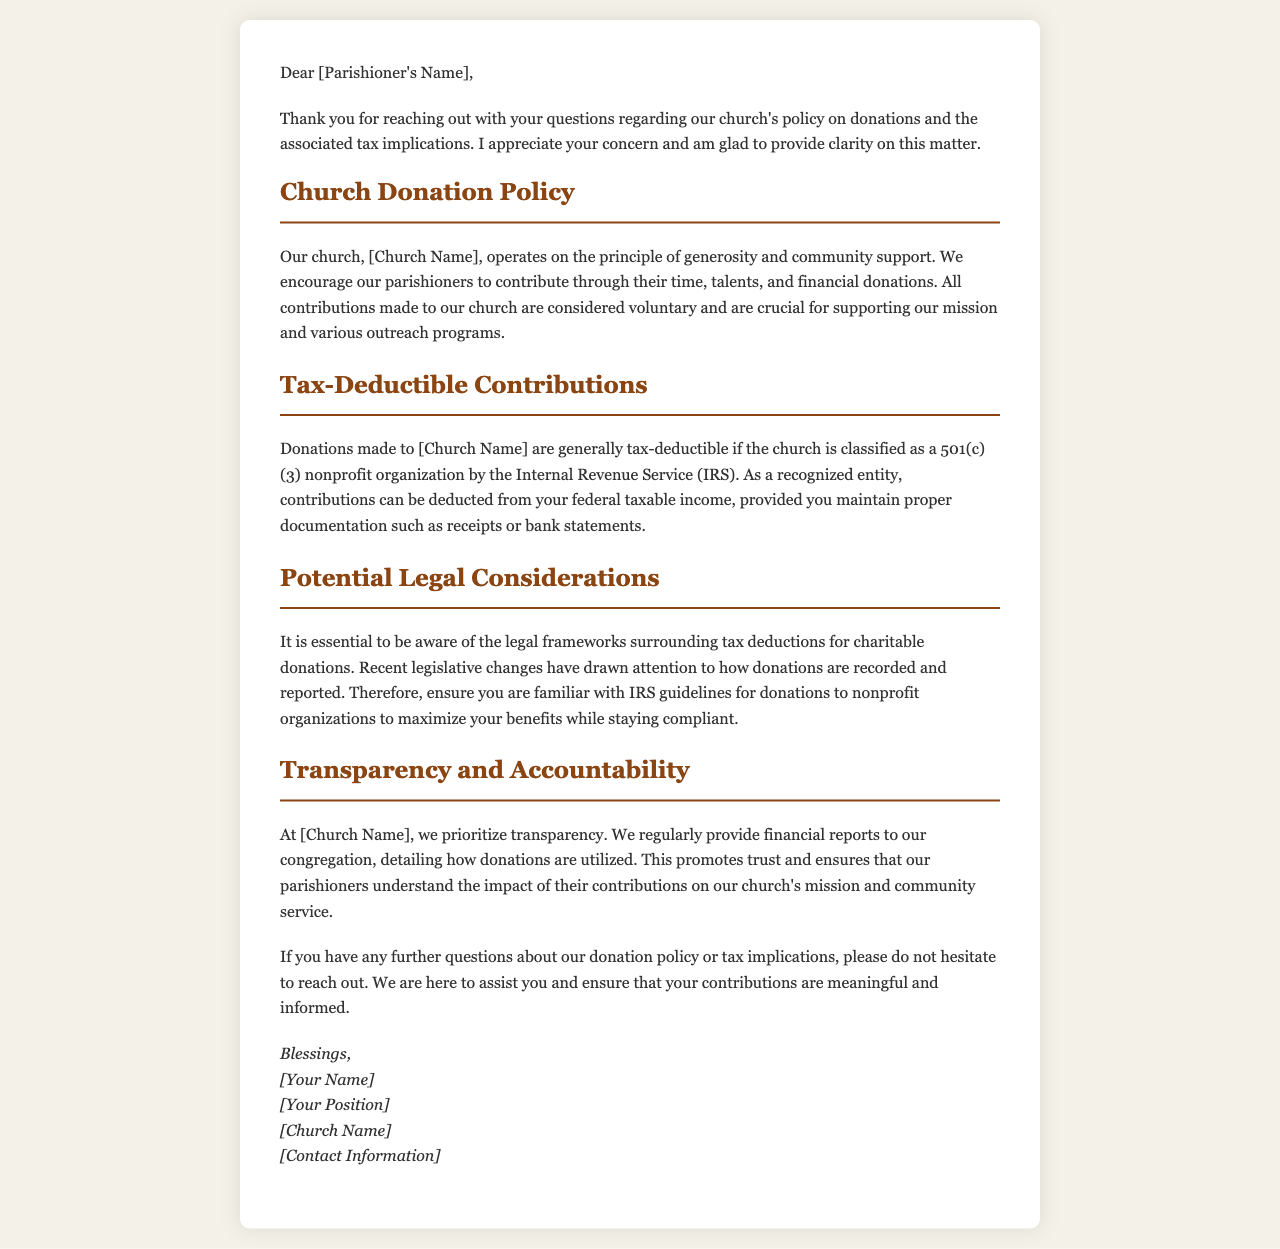What is the church's principle of operation? The church operates on the principle of generosity and community support, indicating its core values and mission.
Answer: Generosity and community support What type of organization is [Church Name] classified as? The church is classified as a 501(c)(3) nonprofit organization by the Internal Revenue Service, which determines tax deduction eligibility.
Answer: 501(c)(3) What must be maintained for tax-deductible donations? Proper documentation such as receipts or bank statements must be kept to substantiate claims for tax deduction eligibility.
Answer: Receipts or bank statements What is prioritized at [Church Name] regarding donations? The church prioritizes transparency, which emphasizes the importance of clear communication about financial matters with parishioners.
Answer: Transparency What should you be familiar with to maximize your donation benefits? It is important to be familiar with IRS guidelines for donations to nonprofit organizations, which guide lawful and advantageous donations.
Answer: IRS guidelines Who is the letter addressing? The letter addresses a specific individual, referred to as the parishioner, reflecting personalized communication.
Answer: [Parishioner's Name] What does the church regularly provide to its congregation? The church regularly provides financial reports, ensuring that parishioners are informed about the use of their contributions.
Answer: Financial reports What does the letter encourage parishioners to do? The letter encourages parishioners to reach out if they have further questions, reflecting the church's supportive stance.
Answer: Reach out What is the closing greeting used in the letter? The closing greeting uses a warm and positive tone, which helps to foster community and connection with the parishioner.
Answer: Blessings 